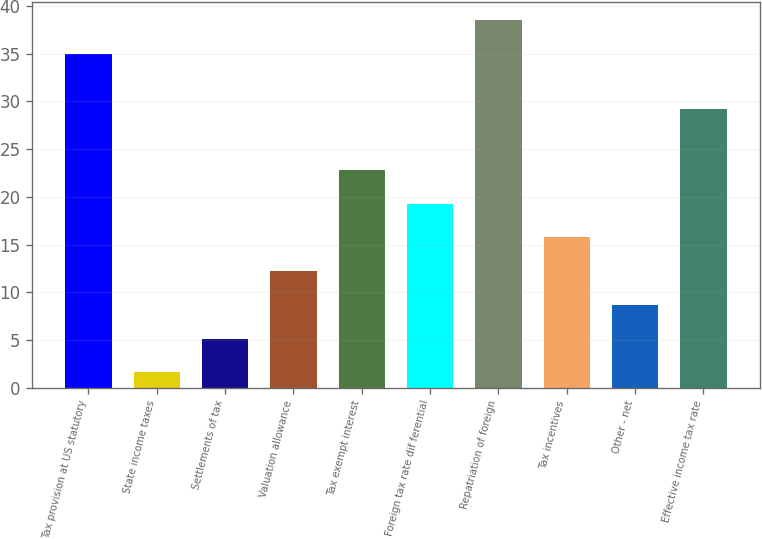Convert chart. <chart><loc_0><loc_0><loc_500><loc_500><bar_chart><fcel>Tax provision at US statutory<fcel>State income taxes<fcel>Settlements of tax<fcel>Valuation allowance<fcel>Tax exempt interest<fcel>Foreign tax rate dif ferential<fcel>Repatriation of foreign<fcel>Tax incentives<fcel>Other - net<fcel>Effective income tax rate<nl><fcel>35<fcel>1.6<fcel>5.14<fcel>12.22<fcel>22.84<fcel>19.3<fcel>38.54<fcel>15.76<fcel>8.68<fcel>29.2<nl></chart> 